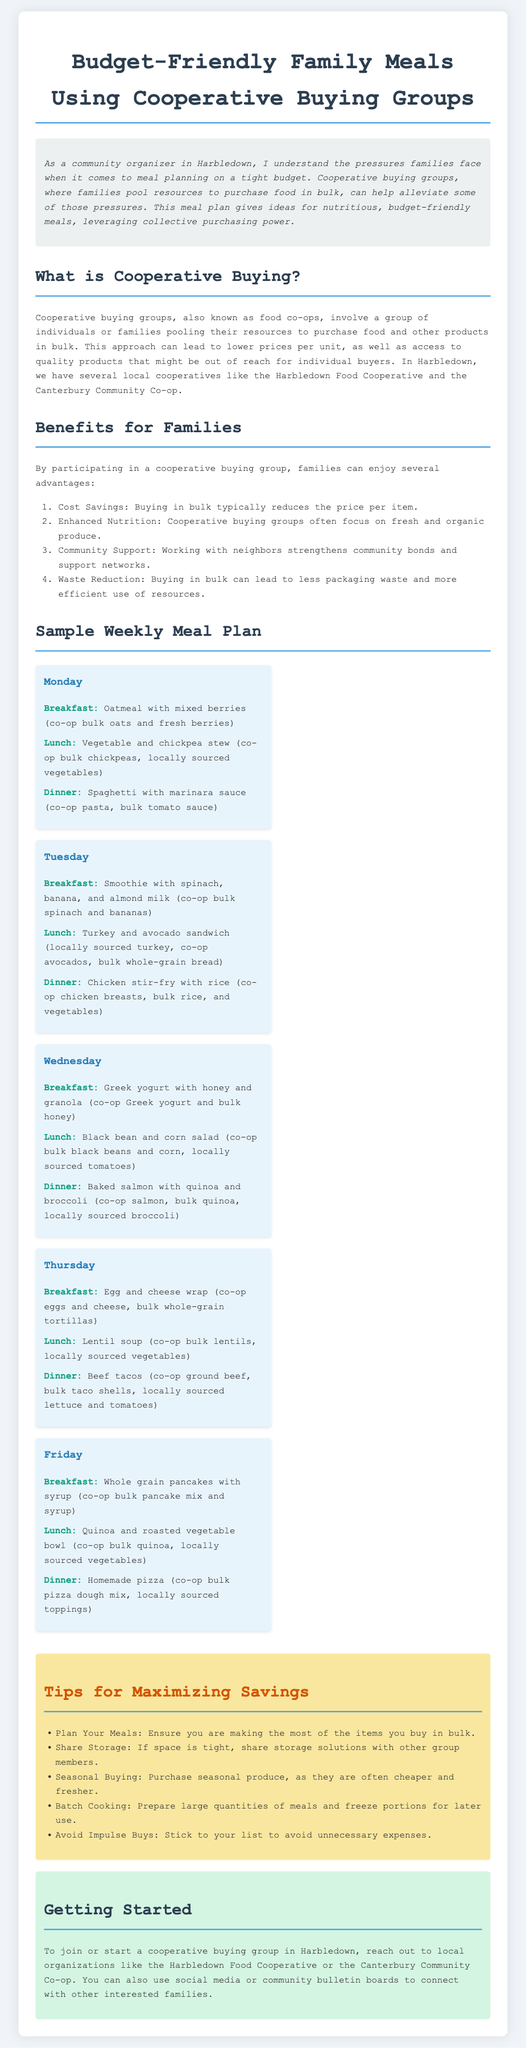What is the title of the document? The title of the document is presented at the top of the rendered page.
Answer: Budget-Friendly Family Meals Using Cooperative Buying Groups What is a benefit of cooperative buying? This information is listed in the "Benefits for Families" section as one of the key advantages.
Answer: Cost Savings Which local cooperative is mentioned in the document? The document references specific cooperatives in Harbledown as examples.
Answer: Harbledown Food Cooperative How many meals are planned for Friday? The "Sample Weekly Meal Plan" section lists three meals for each day of the week.
Answer: 3 What is the suggested breakfast for Wednesday? This meal can be found under the meals listed for Wednesday in the meal plan section.
Answer: Greek yogurt with honey and granola Which organization can help start a cooperative buying group in Harbledown? The document provides specific organizations to contact for getting started with groups.
Answer: Harbledown Food Cooperative What strategy is provided for saving money? The document includes several tips aimed at maximizing savings, prominently featured in a dedicated section.
Answer: Plan Your Meals What type of produce do cooperative buying groups often focus on? The document highlights the nutritional aspects of cooperative buying in relation to specific food items.
Answer: Fresh and organic 